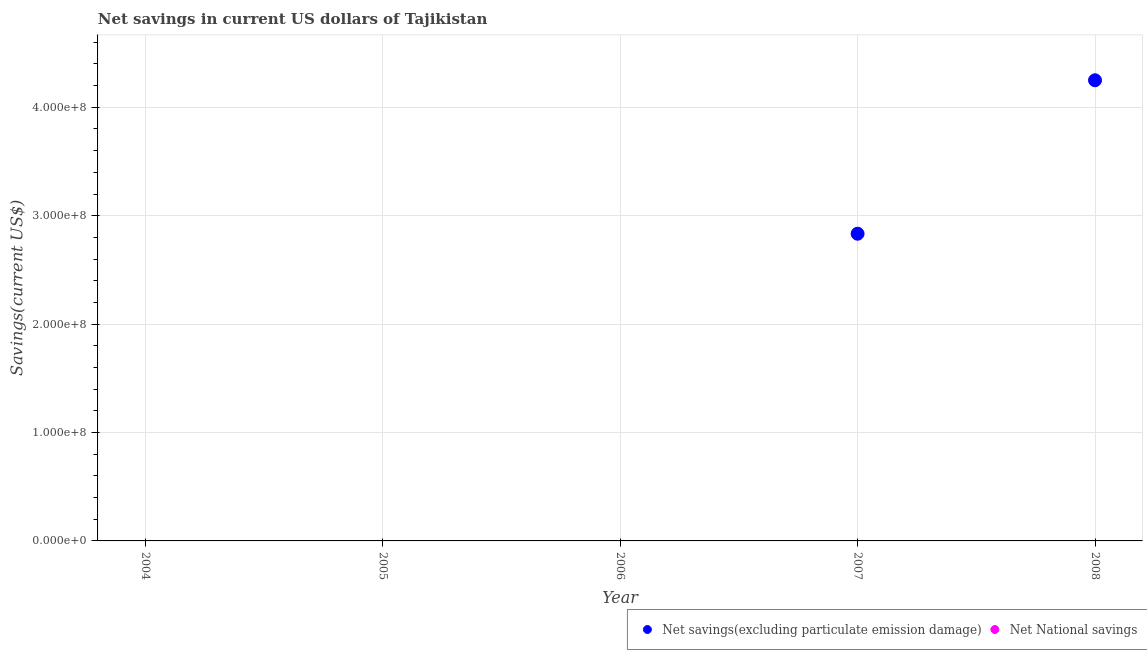Is the number of dotlines equal to the number of legend labels?
Your response must be concise. No. Across all years, what is the maximum net savings(excluding particulate emission damage)?
Your answer should be compact. 4.25e+08. Across all years, what is the minimum net savings(excluding particulate emission damage)?
Offer a very short reply. 0. In which year was the net savings(excluding particulate emission damage) maximum?
Give a very brief answer. 2008. What is the total net savings(excluding particulate emission damage) in the graph?
Make the answer very short. 7.08e+08. What is the difference between the net savings(excluding particulate emission damage) in 2008 and the net national savings in 2005?
Keep it short and to the point. 4.25e+08. What is the average net savings(excluding particulate emission damage) per year?
Provide a short and direct response. 1.42e+08. In how many years, is the net savings(excluding particulate emission damage) greater than 240000000 US$?
Keep it short and to the point. 2. What is the difference between the highest and the lowest net savings(excluding particulate emission damage)?
Your answer should be compact. 4.25e+08. Is the net national savings strictly less than the net savings(excluding particulate emission damage) over the years?
Provide a succinct answer. No. What is the difference between two consecutive major ticks on the Y-axis?
Provide a short and direct response. 1.00e+08. Does the graph contain any zero values?
Provide a succinct answer. Yes. How many legend labels are there?
Make the answer very short. 2. How are the legend labels stacked?
Provide a short and direct response. Horizontal. What is the title of the graph?
Your answer should be very brief. Net savings in current US dollars of Tajikistan. Does "Female labor force" appear as one of the legend labels in the graph?
Your answer should be very brief. No. What is the label or title of the Y-axis?
Offer a terse response. Savings(current US$). What is the Savings(current US$) of Net savings(excluding particulate emission damage) in 2005?
Give a very brief answer. 0. What is the Savings(current US$) of Net savings(excluding particulate emission damage) in 2006?
Your response must be concise. 0. What is the Savings(current US$) of Net National savings in 2006?
Give a very brief answer. 0. What is the Savings(current US$) in Net savings(excluding particulate emission damage) in 2007?
Your response must be concise. 2.83e+08. What is the Savings(current US$) of Net savings(excluding particulate emission damage) in 2008?
Offer a very short reply. 4.25e+08. Across all years, what is the maximum Savings(current US$) in Net savings(excluding particulate emission damage)?
Provide a short and direct response. 4.25e+08. Across all years, what is the minimum Savings(current US$) in Net savings(excluding particulate emission damage)?
Provide a short and direct response. 0. What is the total Savings(current US$) of Net savings(excluding particulate emission damage) in the graph?
Ensure brevity in your answer.  7.08e+08. What is the difference between the Savings(current US$) of Net savings(excluding particulate emission damage) in 2007 and that in 2008?
Offer a terse response. -1.42e+08. What is the average Savings(current US$) in Net savings(excluding particulate emission damage) per year?
Provide a short and direct response. 1.42e+08. What is the average Savings(current US$) in Net National savings per year?
Ensure brevity in your answer.  0. What is the ratio of the Savings(current US$) in Net savings(excluding particulate emission damage) in 2007 to that in 2008?
Your answer should be compact. 0.67. What is the difference between the highest and the lowest Savings(current US$) of Net savings(excluding particulate emission damage)?
Offer a very short reply. 4.25e+08. 